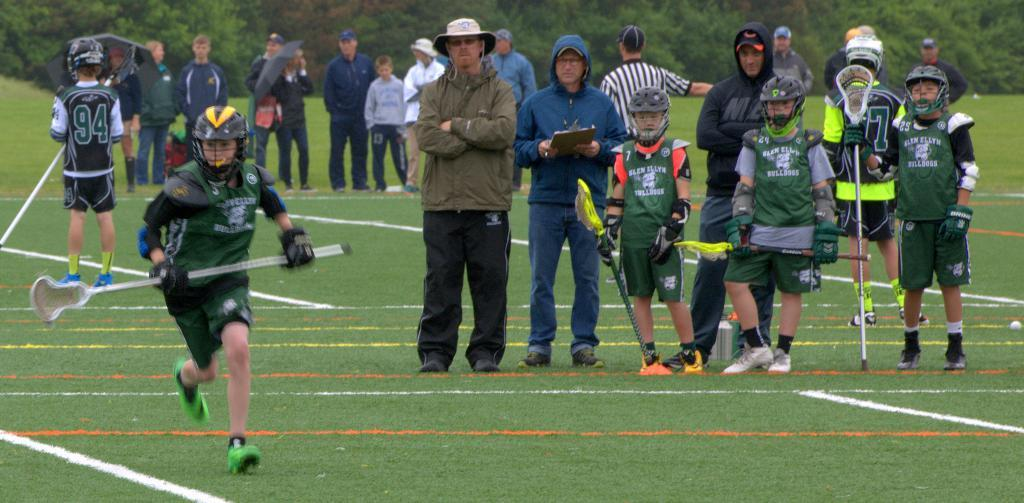How many individuals are present in the image? There are many people in the image. Can you identify any specific groups of people in the image? Yes, there are children in the image. What safety precaution are some of the children taking? Some children are wearing helmets. What activity are the children engaged in? The children are catching sticks with their hands. What can be seen in the distance in the image? There are trees visible in the background of the image. How long does it take for the girl to play the drum in the image? There is no girl or drum present in the image. 